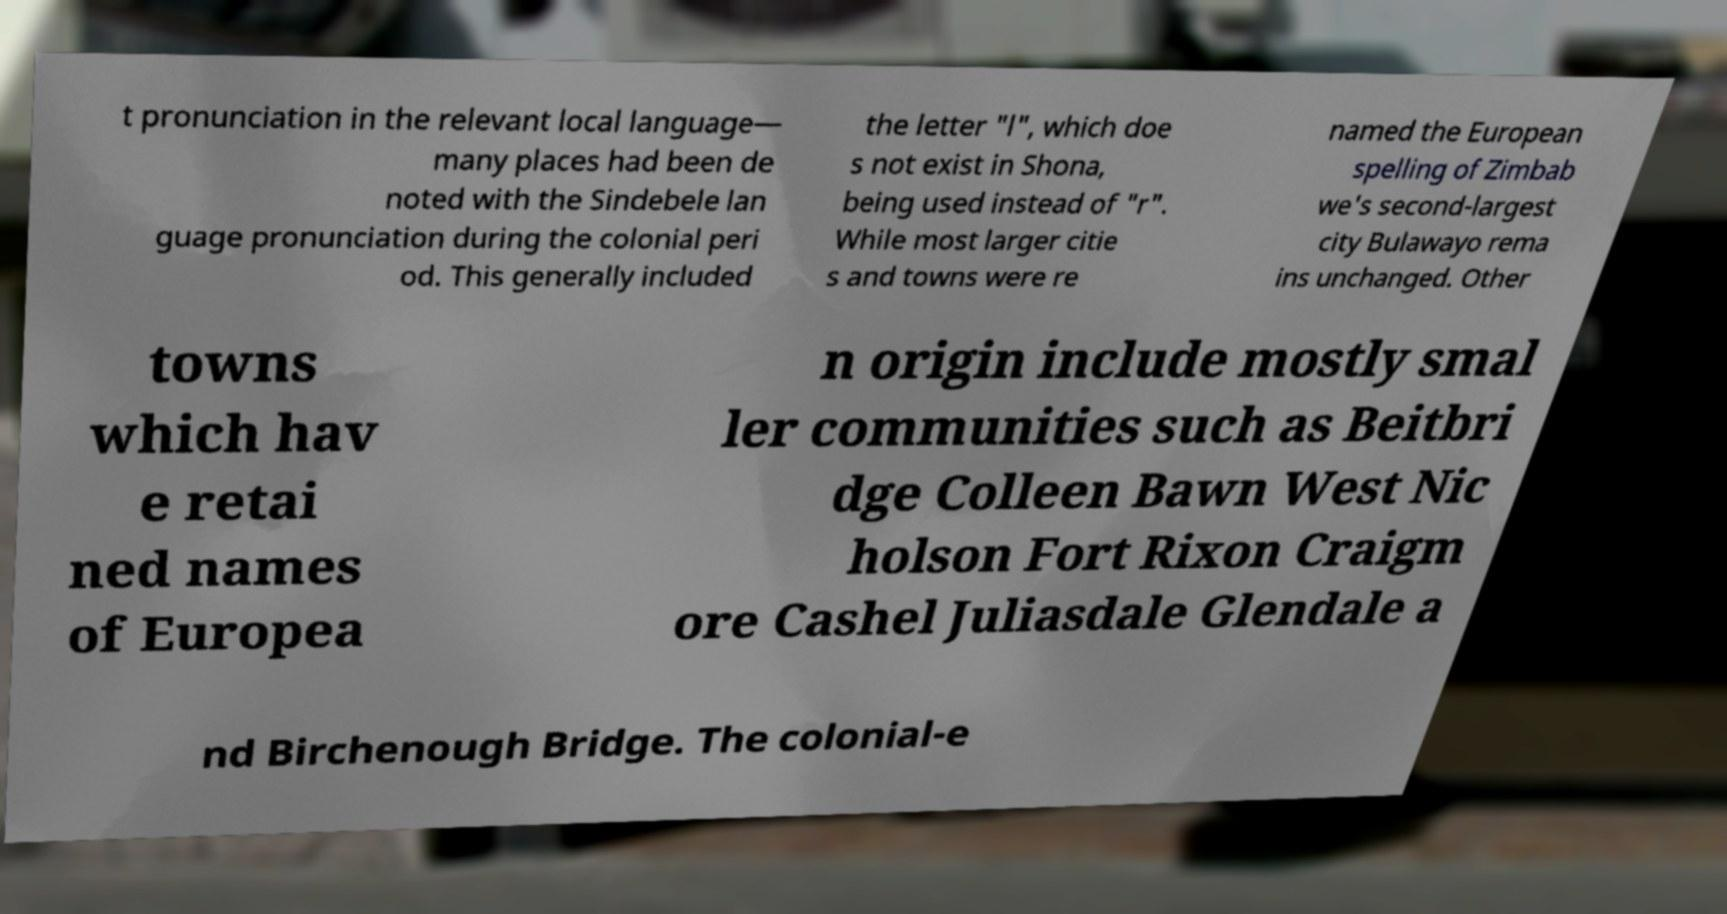Could you assist in decoding the text presented in this image and type it out clearly? t pronunciation in the relevant local language— many places had been de noted with the Sindebele lan guage pronunciation during the colonial peri od. This generally included the letter "l", which doe s not exist in Shona, being used instead of "r". While most larger citie s and towns were re named the European spelling of Zimbab we's second-largest city Bulawayo rema ins unchanged. Other towns which hav e retai ned names of Europea n origin include mostly smal ler communities such as Beitbri dge Colleen Bawn West Nic holson Fort Rixon Craigm ore Cashel Juliasdale Glendale a nd Birchenough Bridge. The colonial-e 